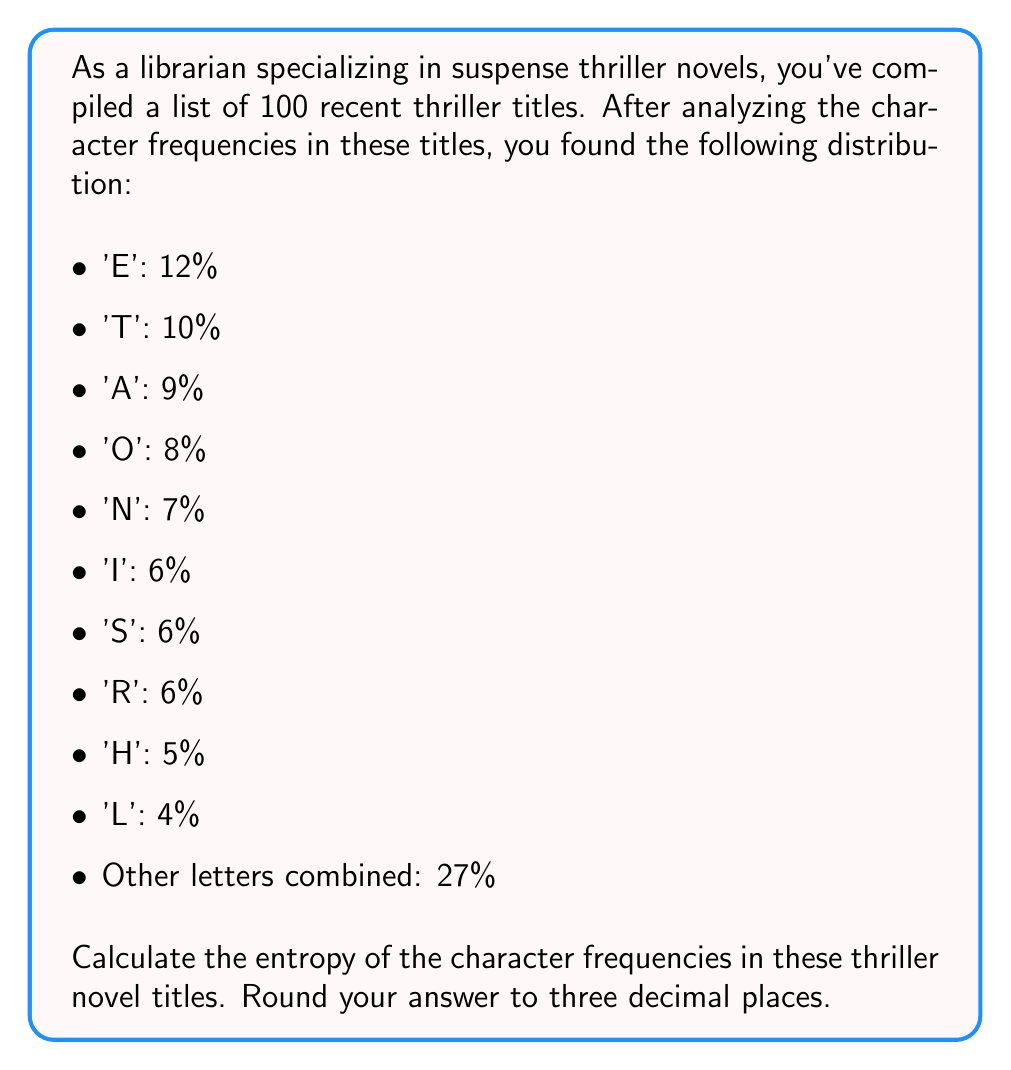Solve this math problem. To calculate the entropy of the character frequencies, we'll use the formula for Shannon entropy:

$$H = -\sum_{i=1}^n p_i \log_2(p_i)$$

Where $p_i$ is the probability of each character occurring, and $n$ is the number of different characters (or character groups in this case).

Let's calculate each term:

1. $-0.12 \log_2(0.12) \approx 0.3679$
2. $-0.10 \log_2(0.10) \approx 0.3322$
3. $-0.09 \log_2(0.09) \approx 0.3120$
4. $-0.08 \log_2(0.08) \approx 0.2915$
5. $-0.07 \log_2(0.07) \approx 0.2703$
6. $-0.06 \log_2(0.06) \approx 0.2442$ (for 'I')
7. $-0.06 \log_2(0.06) \approx 0.2442$ (for 'S')
8. $-0.06 \log_2(0.06) \approx 0.2442$ (for 'R')
9. $-0.05 \log_2(0.05) \approx 0.2161$
10. $-0.04 \log_2(0.04) \approx 0.1857$
11. $-0.27 \log_2(0.27) \approx 0.5097$

Now, we sum all these terms:

$$H = 0.3679 + 0.3322 + 0.3120 + 0.2915 + 0.2703 + 0.2442 + 0.2442 + 0.2442 + 0.2161 + 0.1857 + 0.5097$$

$$H \approx 3.2180$$

Rounding to three decimal places, we get 3.218 bits.
Answer: 3.218 bits 